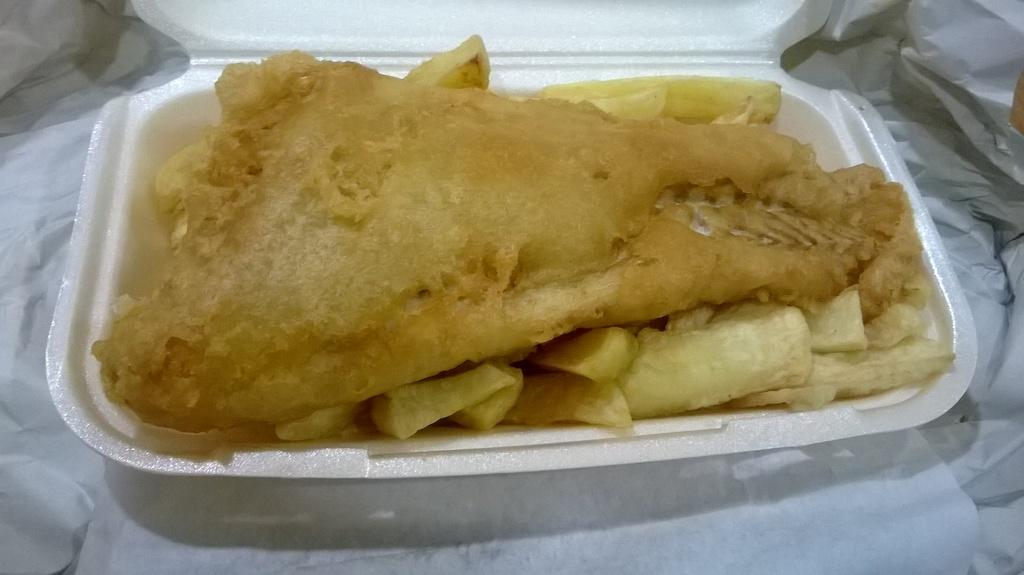What type of container is holding the food in the image? There is food in a to-go box in the image. What other item can be seen in the image besides the food container? There is a white-colored paper in the image. What type of print can be seen on the dog's collar in the image? There is no dog present in the image, so it is not possible to determine what, if any, print might be on a dog's collar. 